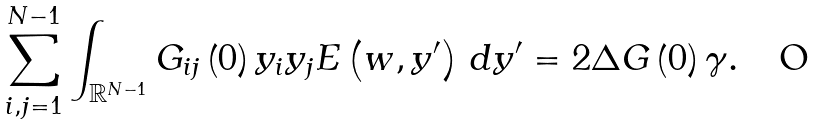<formula> <loc_0><loc_0><loc_500><loc_500>\sum _ { i , j = 1 } ^ { N - 1 } \int _ { \mathbb { R } ^ { N - 1 } } G _ { i j } \left ( 0 \right ) y _ { i } y _ { j } E \left ( w , y ^ { \prime } \right ) \, d y ^ { \prime } = 2 \Delta G \left ( 0 \right ) \gamma .</formula> 